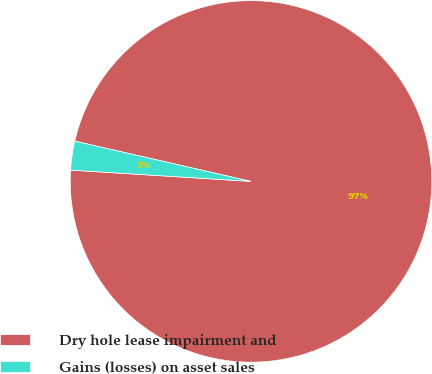<chart> <loc_0><loc_0><loc_500><loc_500><pie_chart><fcel>Dry hole lease impairment and<fcel>Gains (losses) on asset sales<nl><fcel>97.42%<fcel>2.58%<nl></chart> 